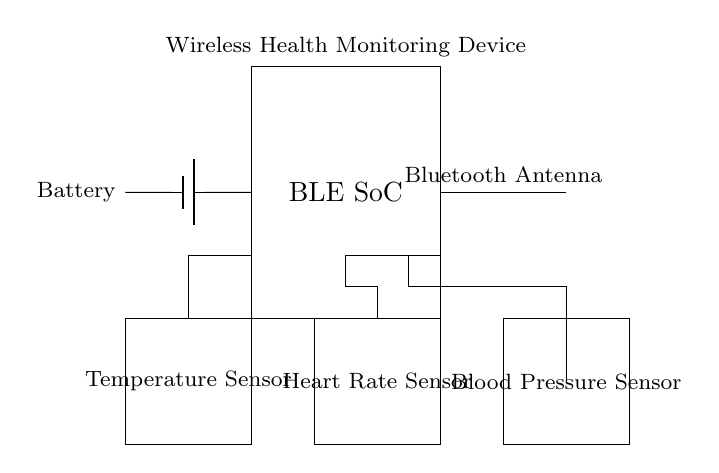What is the main component of this circuit? The main component labeled in the circuit is the BLE SoC, which represents the Bluetooth Low Energy System on Chip. This indicates that it is the central processing unit for wireless communication in the circuit.
Answer: BLE SoC What type of sensors are included in the circuit? The circuit includes three specific types of sensors: a Temperature Sensor, a Heart Rate Sensor, and a Blood Pressure Sensor. Each sensor is represented by a labeled rectangle in the diagram.
Answer: Temperature, Heart Rate, Blood Pressure What is the role of the antenna in this circuit? The antenna facilitates wireless communication by sending and receiving Bluetooth signals. It's depicted connecting to the BLE SoC, indicating its critical role in enabling the device's wireless functionality.
Answer: Wireless communication How many sensors are connected to the BLE SoC? There are three sensors connected to the BLE SoC, as indicated by the connections leading from the sensor components to the BLE SoC. Each sensor is drawn in close proximity to the BLE device, showing direct connectivity.
Answer: Three What is the power source for this circuit? The power source is a Battery, as labeled on the diagram. It provides the necessary voltage to the entire circuit, enabling the operation of the sensors and BLE SoC.
Answer: Battery What type of connection is used between the sensors and the BLE SoC? The connections are conductive lines, which represent electrical connections integrating the signals from the sensors with the BLE SoC for processing data. This is necessary for the functioning of the health monitoring device.
Answer: Conductive lines What is the significance of Bluetooth in this health monitoring device? Bluetooth technology is crucial in this device as it enables secure and low-energy communication between the health sensors and external devices like smartphones, facilitating real-time monitoring and data sharing.
Answer: Secure, low-energy communication 